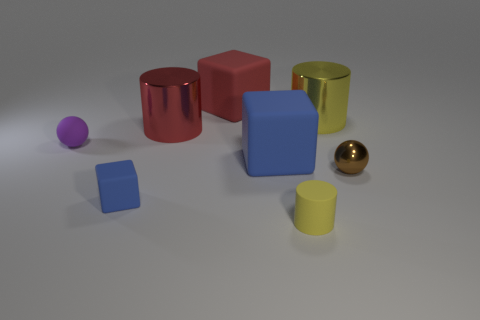Add 2 small blue matte things. How many objects exist? 10 Subtract all cylinders. How many objects are left? 5 Subtract all matte cylinders. Subtract all yellow metal cylinders. How many objects are left? 6 Add 6 red cylinders. How many red cylinders are left? 7 Add 3 small shiny balls. How many small shiny balls exist? 4 Subtract 0 gray blocks. How many objects are left? 8 